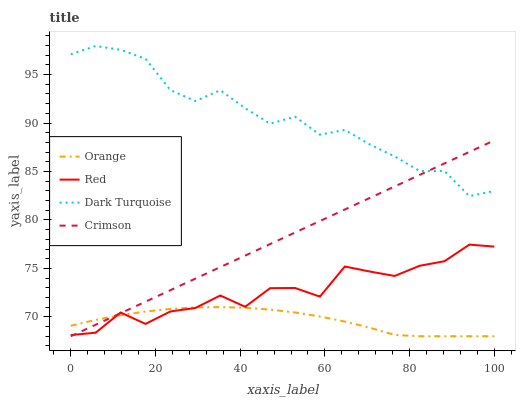Does Orange have the minimum area under the curve?
Answer yes or no. Yes. Does Dark Turquoise have the maximum area under the curve?
Answer yes or no. Yes. Does Crimson have the minimum area under the curve?
Answer yes or no. No. Does Crimson have the maximum area under the curve?
Answer yes or no. No. Is Crimson the smoothest?
Answer yes or no. Yes. Is Red the roughest?
Answer yes or no. Yes. Is Dark Turquoise the smoothest?
Answer yes or no. No. Is Dark Turquoise the roughest?
Answer yes or no. No. Does Orange have the lowest value?
Answer yes or no. Yes. Does Dark Turquoise have the lowest value?
Answer yes or no. No. Does Dark Turquoise have the highest value?
Answer yes or no. Yes. Does Crimson have the highest value?
Answer yes or no. No. Is Orange less than Dark Turquoise?
Answer yes or no. Yes. Is Dark Turquoise greater than Orange?
Answer yes or no. Yes. Does Orange intersect Crimson?
Answer yes or no. Yes. Is Orange less than Crimson?
Answer yes or no. No. Is Orange greater than Crimson?
Answer yes or no. No. Does Orange intersect Dark Turquoise?
Answer yes or no. No. 